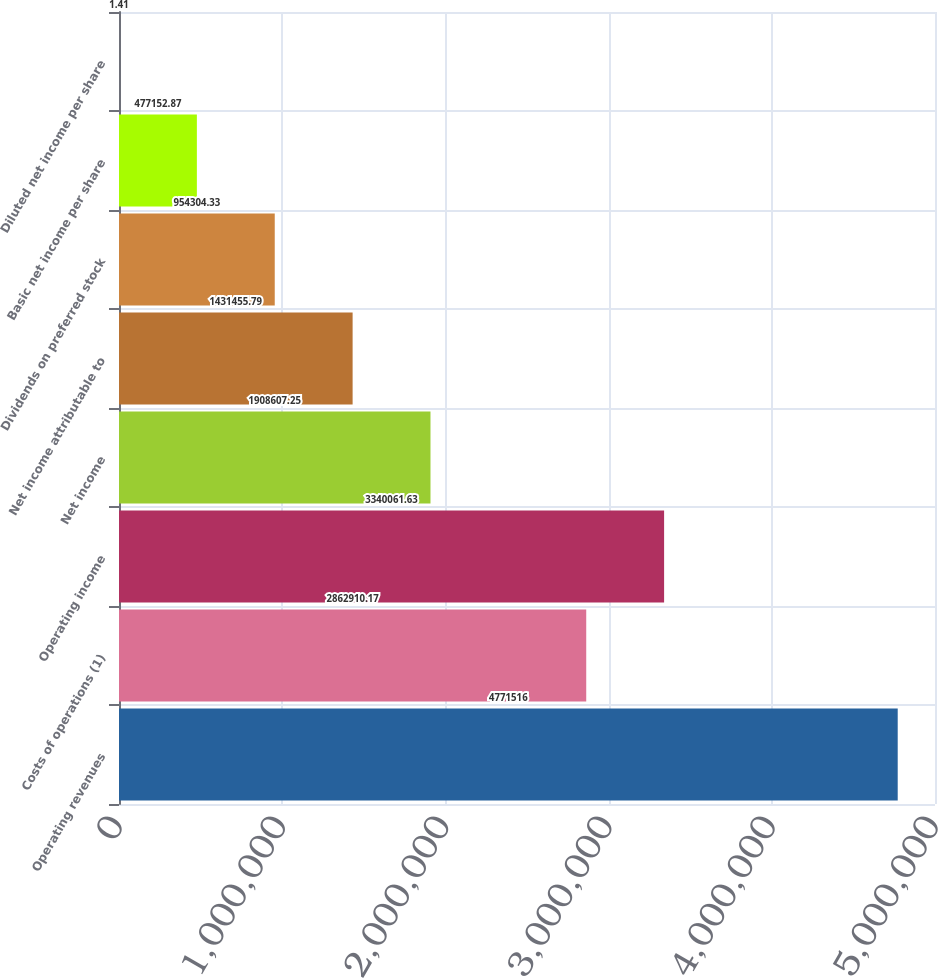Convert chart to OTSL. <chart><loc_0><loc_0><loc_500><loc_500><bar_chart><fcel>Operating revenues<fcel>Costs of operations (1)<fcel>Operating income<fcel>Net income<fcel>Net income attributable to<fcel>Dividends on preferred stock<fcel>Basic net income per share<fcel>Diluted net income per share<nl><fcel>4.77152e+06<fcel>2.86291e+06<fcel>3.34006e+06<fcel>1.90861e+06<fcel>1.43146e+06<fcel>954304<fcel>477153<fcel>1.41<nl></chart> 